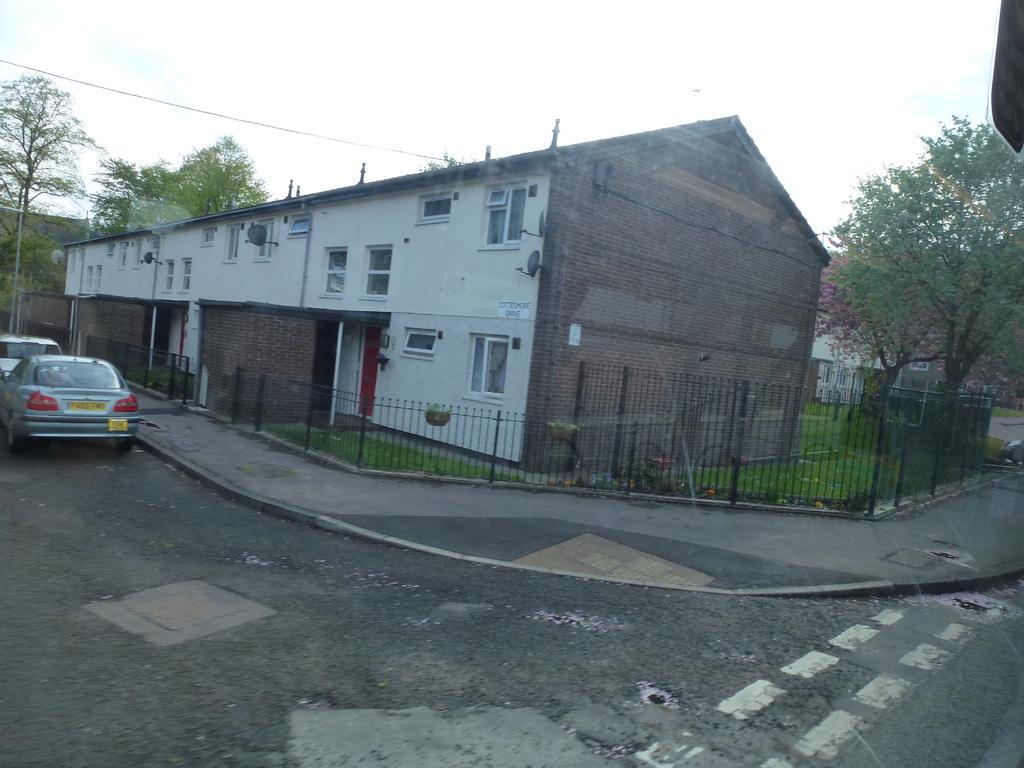Could you give a brief overview of what you see in this image? In this picture we can see shed house in the center of the image. In the front we can see black fencing railing and some trees. In front bottom side we can see the road and some cars are parked. On the top we can see the sky and clouds. 